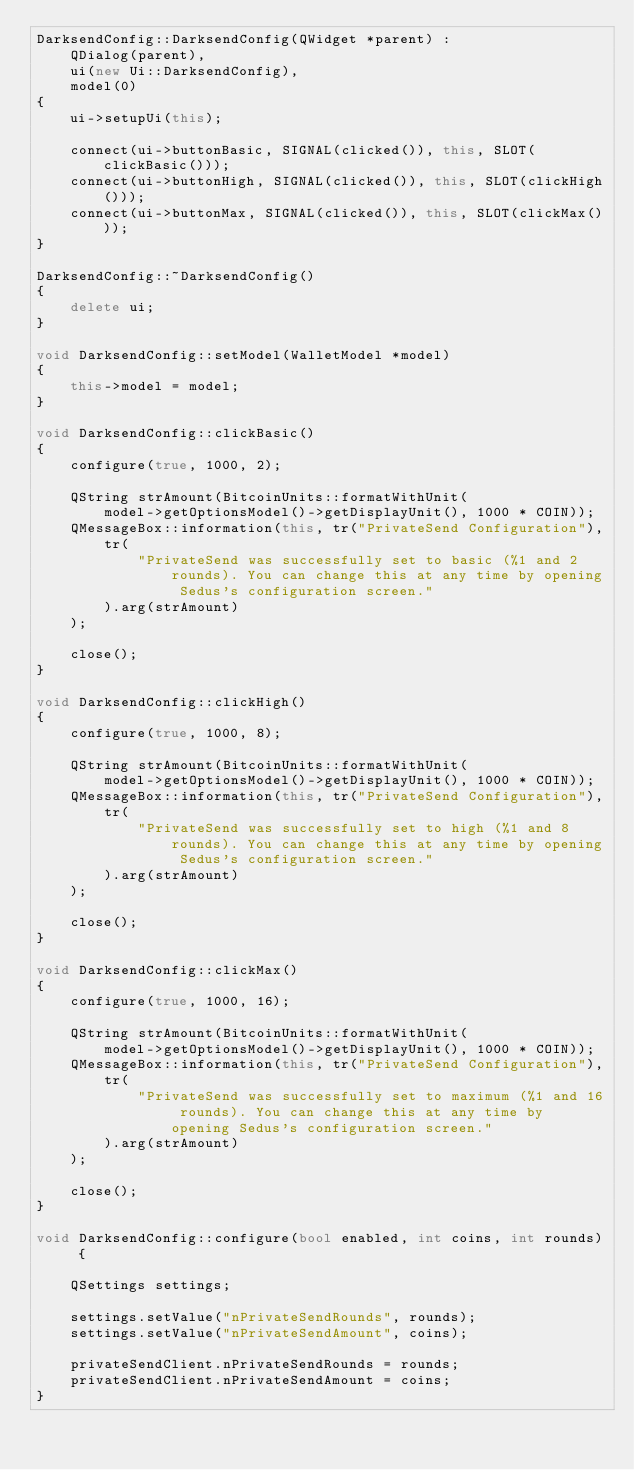<code> <loc_0><loc_0><loc_500><loc_500><_C++_>DarksendConfig::DarksendConfig(QWidget *parent) :
    QDialog(parent),
    ui(new Ui::DarksendConfig),
    model(0)
{
    ui->setupUi(this);

    connect(ui->buttonBasic, SIGNAL(clicked()), this, SLOT(clickBasic()));
    connect(ui->buttonHigh, SIGNAL(clicked()), this, SLOT(clickHigh()));
    connect(ui->buttonMax, SIGNAL(clicked()), this, SLOT(clickMax()));
}

DarksendConfig::~DarksendConfig()
{
    delete ui;
}

void DarksendConfig::setModel(WalletModel *model)
{
    this->model = model;
}

void DarksendConfig::clickBasic()
{
    configure(true, 1000, 2);

    QString strAmount(BitcoinUnits::formatWithUnit(
        model->getOptionsModel()->getDisplayUnit(), 1000 * COIN));
    QMessageBox::information(this, tr("PrivateSend Configuration"),
        tr(
            "PrivateSend was successfully set to basic (%1 and 2 rounds). You can change this at any time by opening Sedus's configuration screen."
        ).arg(strAmount)
    );

    close();
}

void DarksendConfig::clickHigh()
{
    configure(true, 1000, 8);

    QString strAmount(BitcoinUnits::formatWithUnit(
        model->getOptionsModel()->getDisplayUnit(), 1000 * COIN));
    QMessageBox::information(this, tr("PrivateSend Configuration"),
        tr(
            "PrivateSend was successfully set to high (%1 and 8 rounds). You can change this at any time by opening Sedus's configuration screen."
        ).arg(strAmount)
    );

    close();
}

void DarksendConfig::clickMax()
{
    configure(true, 1000, 16);

    QString strAmount(BitcoinUnits::formatWithUnit(
        model->getOptionsModel()->getDisplayUnit(), 1000 * COIN));
    QMessageBox::information(this, tr("PrivateSend Configuration"),
        tr(
            "PrivateSend was successfully set to maximum (%1 and 16 rounds). You can change this at any time by opening Sedus's configuration screen."
        ).arg(strAmount)
    );

    close();
}

void DarksendConfig::configure(bool enabled, int coins, int rounds) {

    QSettings settings;

    settings.setValue("nPrivateSendRounds", rounds);
    settings.setValue("nPrivateSendAmount", coins);

    privateSendClient.nPrivateSendRounds = rounds;
    privateSendClient.nPrivateSendAmount = coins;
}
</code> 